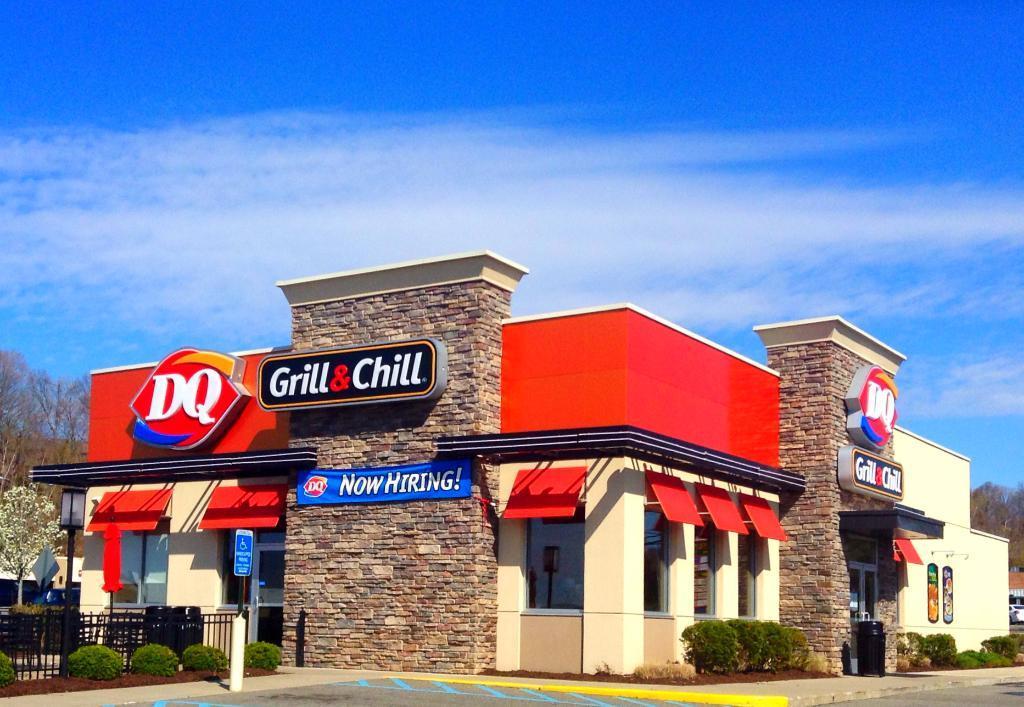Could you give a brief overview of what you see in this image? In the given picture, I can see a restaurant towards left, I can see few tiny trees, Towards right we can see a gate from where we get access to go inside and even here we can see a tiny trees and behind the restaurant , we can see trees, sky and a road. 